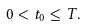Convert formula to latex. <formula><loc_0><loc_0><loc_500><loc_500>0 < t _ { 0 } \leq T .</formula> 